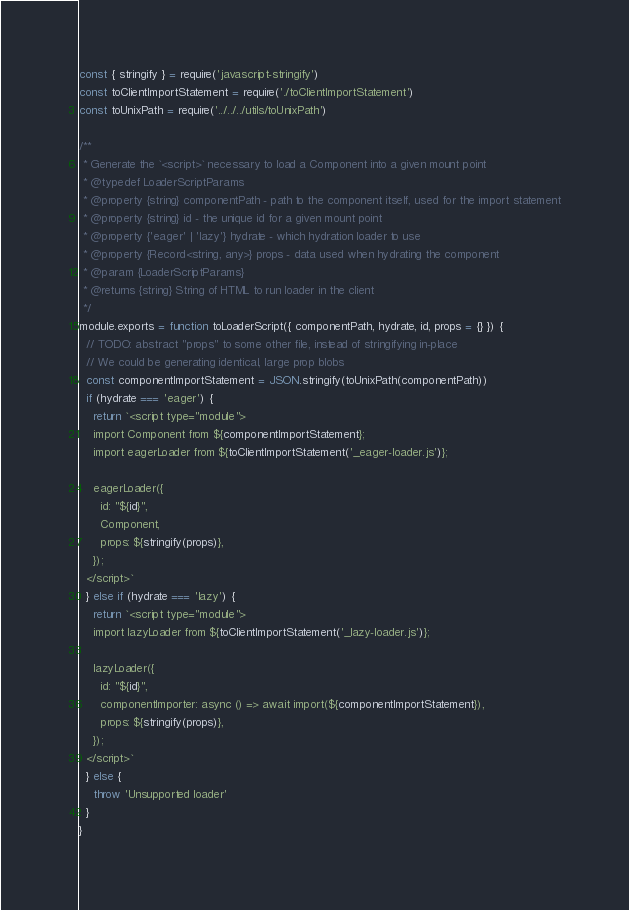<code> <loc_0><loc_0><loc_500><loc_500><_JavaScript_>const { stringify } = require('javascript-stringify')
const toClientImportStatement = require('./toClientImportStatement')
const toUnixPath = require('../../../utils/toUnixPath')

/**
 * Generate the `<script>` necessary to load a Component into a given mount point
 * @typedef LoaderScriptParams
 * @property {string} componentPath - path to the component itself, used for the import statement
 * @property {string} id - the unique id for a given mount point
 * @property {'eager' | 'lazy'} hydrate - which hydration loader to use
 * @property {Record<string, any>} props - data used when hydrating the component
 * @param {LoaderScriptParams}
 * @returns {string} String of HTML to run loader in the client
 */
module.exports = function toLoaderScript({ componentPath, hydrate, id, props = {} }) {
  // TODO: abstract "props" to some other file, instead of stringifying in-place
  // We could be generating identical, large prop blobs
  const componentImportStatement = JSON.stringify(toUnixPath(componentPath))
  if (hydrate === 'eager') {
    return `<script type="module">
    import Component from ${componentImportStatement};
    import eagerLoader from ${toClientImportStatement('_eager-loader.js')};
  
    eagerLoader({ 
      id: "${id}",
      Component,
      props: ${stringify(props)},
    });
  </script>`
  } else if (hydrate === 'lazy') {
    return `<script type="module">
    import lazyLoader from ${toClientImportStatement('_lazy-loader.js')};
  
    lazyLoader({ 
      id: "${id}",
      componentImporter: async () => await import(${componentImportStatement}),
      props: ${stringify(props)},
    });
  </script>`
  } else {
    throw 'Unsupported loader'
  }
}
</code> 